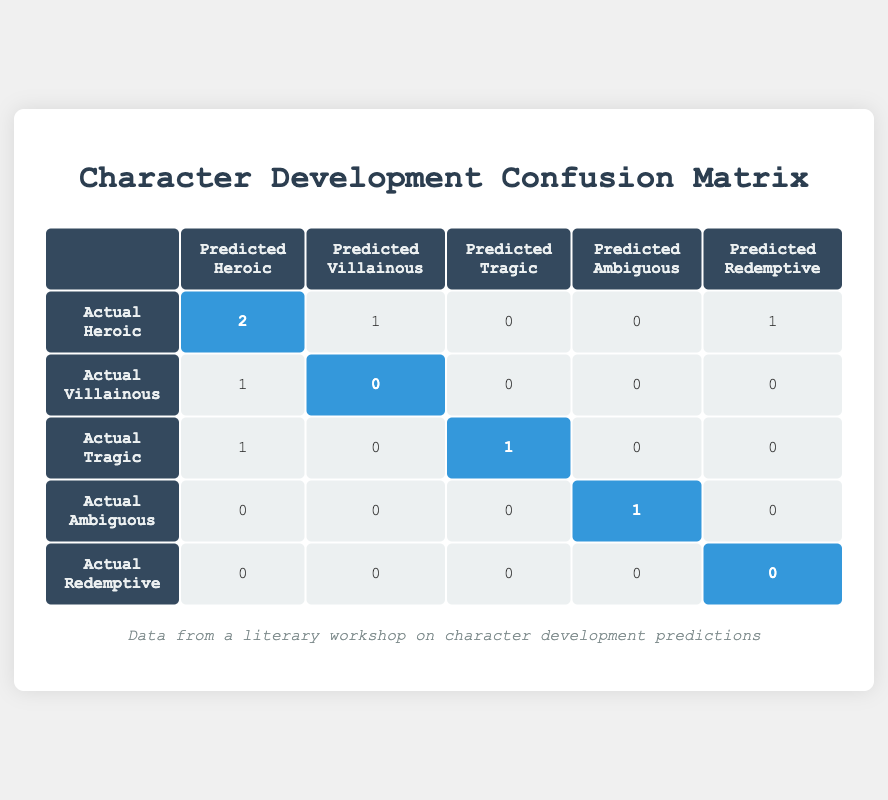What is the total number of characters predicted to be Heroic? In the "Predicted Heroic" column, I need to count the occurrences of predictions that were considered Heroic. From the table, there are 2 characters (Evelyn Carter and Peter Gill) who have both their predicted and actual developments as Heroic, and 1 character (Sophie Rivers) who is predicted Heroic but is actually Heroic. Thus, the total is 2 + 1 = 3 characters predicted to be Heroic.
Answer: 3 How many characters were inaccurately predicted as Villainous? In the "Predicted Villainous" column, I will find the characters that were actually Heroic or Tragic but were predicted to be Villainous. From the table, there is only 1 character, Marcus Flint, who was predicted as Villainous but was actually Heroic. Therefore, there is 1 inaccurate prediction in this category.
Answer: 1 Was there any character considered Redemptive in the actual development? I will look at the "Actual Redemptive" row to check if there are any counts. According to the table, the count is 0, meaning no character was developed as Redemptive. So, the answer is no, there were no Redemptive characters in actual development.
Answer: No What is the total number of characters whose actual development was Tragic? To find this, I will look at the "Actual Tragic" row and count the total occurrences. There are 1 character identified (Lila Monroe), but also 1 character (Victor Drew) whose predicted development was Heroic but whose actual development was Tragic. The total count for actual development Tragic is thus 1 + 1 = 2.
Answer: 2 How many characters predicted to be Heroic were actually Tragic? I will refer to the intersection of "Predicted Heroic" and "Actual Tragic." There is 1 character, Victor Drew, who was predicted Heroic but is actually Tragic. Hence, there is only 1 character that fit this description.
Answer: 1 How many characters were correctly predicted as Ambiguous? In the "Predicted Ambiguous" column, I will identify characters whose prediction matches their actual development. According to the table, there is only 1 character (Cecilia Lane) whose predicted development matches its actual development, hence the count is 1.
Answer: 1 What percentage of characters predicted as Heroic were actually correct? First, I need to find the count of characters predicted as Heroic. There are a total of 3 characters who fit this category (Evelyn Carter, Peter Gill, and Sophie Rivers). Out of these, 2 were actually Heroic (Evelyn Carter and Peter Gill). The correct prediction percentage is (2 correct / 3 total) * 100 = 66.67%.
Answer: 66.67% Which prediction type had the most inaccuracies? I will analyze the predictions and actual developments across all categories. The "Predicted Villainous" had 1 character inaccurately predicted (Marcus Flint), while "Predicted Heroic" had 1 (Victor Drew). The categories like Tragic, Ambiguous, and Redemptive did not have inaccuracies. Therefore, both Villainous and Heroic predictions were the most inaccurate, each having 1 character.
Answer: Heroic and Villainous 